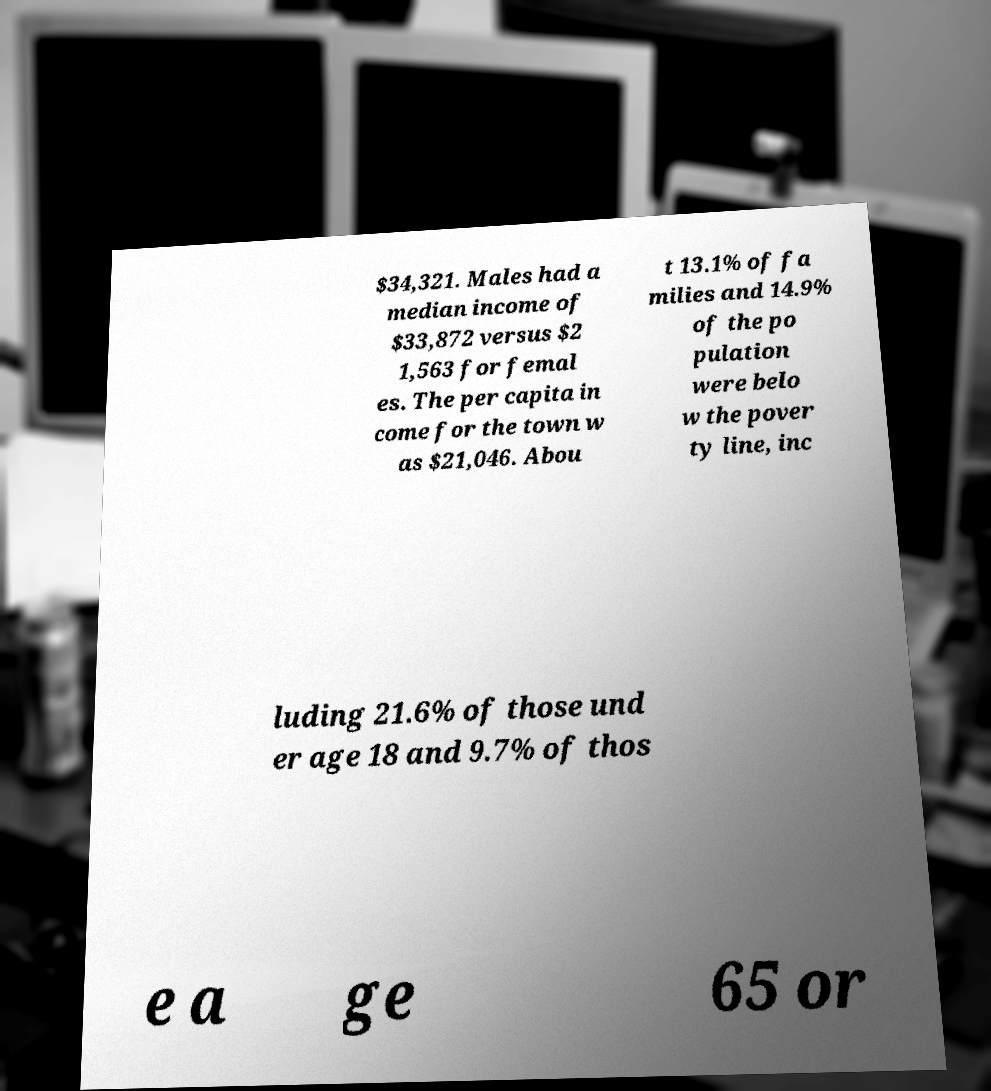Could you assist in decoding the text presented in this image and type it out clearly? $34,321. Males had a median income of $33,872 versus $2 1,563 for femal es. The per capita in come for the town w as $21,046. Abou t 13.1% of fa milies and 14.9% of the po pulation were belo w the pover ty line, inc luding 21.6% of those und er age 18 and 9.7% of thos e a ge 65 or 